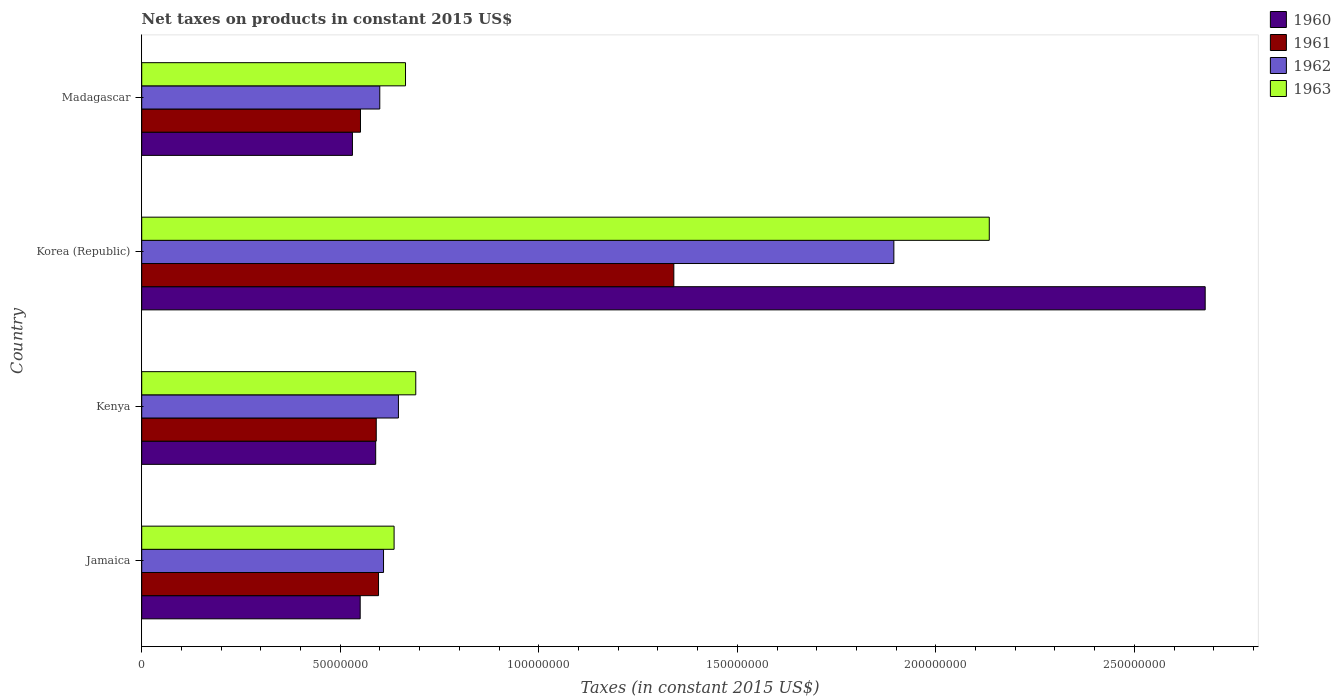Are the number of bars per tick equal to the number of legend labels?
Your answer should be very brief. Yes. Are the number of bars on each tick of the Y-axis equal?
Keep it short and to the point. Yes. How many bars are there on the 3rd tick from the bottom?
Your answer should be compact. 4. What is the label of the 2nd group of bars from the top?
Offer a terse response. Korea (Republic). In how many cases, is the number of bars for a given country not equal to the number of legend labels?
Your answer should be very brief. 0. What is the net taxes on products in 1961 in Madagascar?
Provide a short and direct response. 5.51e+07. Across all countries, what is the maximum net taxes on products in 1961?
Make the answer very short. 1.34e+08. Across all countries, what is the minimum net taxes on products in 1961?
Offer a very short reply. 5.51e+07. In which country was the net taxes on products in 1962 minimum?
Your answer should be very brief. Madagascar. What is the total net taxes on products in 1963 in the graph?
Provide a succinct answer. 4.12e+08. What is the difference between the net taxes on products in 1963 in Kenya and that in Madagascar?
Keep it short and to the point. 2.58e+06. What is the difference between the net taxes on products in 1962 in Jamaica and the net taxes on products in 1960 in Kenya?
Offer a very short reply. 1.97e+06. What is the average net taxes on products in 1961 per country?
Your answer should be compact. 7.70e+07. What is the difference between the net taxes on products in 1961 and net taxes on products in 1960 in Jamaica?
Your answer should be very brief. 4.62e+06. What is the ratio of the net taxes on products in 1960 in Jamaica to that in Korea (Republic)?
Your answer should be compact. 0.21. Is the difference between the net taxes on products in 1961 in Jamaica and Kenya greater than the difference between the net taxes on products in 1960 in Jamaica and Kenya?
Your answer should be very brief. Yes. What is the difference between the highest and the second highest net taxes on products in 1961?
Your answer should be very brief. 7.44e+07. What is the difference between the highest and the lowest net taxes on products in 1963?
Make the answer very short. 1.50e+08. Is the sum of the net taxes on products in 1961 in Kenya and Korea (Republic) greater than the maximum net taxes on products in 1960 across all countries?
Ensure brevity in your answer.  No. What does the 4th bar from the bottom in Madagascar represents?
Offer a terse response. 1963. Are all the bars in the graph horizontal?
Your response must be concise. Yes. How many countries are there in the graph?
Give a very brief answer. 4. What is the difference between two consecutive major ticks on the X-axis?
Your answer should be very brief. 5.00e+07. Are the values on the major ticks of X-axis written in scientific E-notation?
Provide a succinct answer. No. Does the graph contain grids?
Make the answer very short. No. Where does the legend appear in the graph?
Make the answer very short. Top right. How many legend labels are there?
Offer a very short reply. 4. How are the legend labels stacked?
Your answer should be very brief. Vertical. What is the title of the graph?
Keep it short and to the point. Net taxes on products in constant 2015 US$. What is the label or title of the X-axis?
Your answer should be compact. Taxes (in constant 2015 US$). What is the Taxes (in constant 2015 US$) in 1960 in Jamaica?
Keep it short and to the point. 5.50e+07. What is the Taxes (in constant 2015 US$) of 1961 in Jamaica?
Offer a terse response. 5.96e+07. What is the Taxes (in constant 2015 US$) of 1962 in Jamaica?
Give a very brief answer. 6.09e+07. What is the Taxes (in constant 2015 US$) of 1963 in Jamaica?
Keep it short and to the point. 6.36e+07. What is the Taxes (in constant 2015 US$) of 1960 in Kenya?
Your answer should be very brief. 5.89e+07. What is the Taxes (in constant 2015 US$) in 1961 in Kenya?
Ensure brevity in your answer.  5.91e+07. What is the Taxes (in constant 2015 US$) in 1962 in Kenya?
Your answer should be very brief. 6.47e+07. What is the Taxes (in constant 2015 US$) in 1963 in Kenya?
Your response must be concise. 6.90e+07. What is the Taxes (in constant 2015 US$) of 1960 in Korea (Republic)?
Make the answer very short. 2.68e+08. What is the Taxes (in constant 2015 US$) in 1961 in Korea (Republic)?
Make the answer very short. 1.34e+08. What is the Taxes (in constant 2015 US$) in 1962 in Korea (Republic)?
Your answer should be very brief. 1.89e+08. What is the Taxes (in constant 2015 US$) in 1963 in Korea (Republic)?
Provide a succinct answer. 2.13e+08. What is the Taxes (in constant 2015 US$) in 1960 in Madagascar?
Your answer should be compact. 5.31e+07. What is the Taxes (in constant 2015 US$) of 1961 in Madagascar?
Your answer should be very brief. 5.51e+07. What is the Taxes (in constant 2015 US$) in 1962 in Madagascar?
Provide a short and direct response. 6.00e+07. What is the Taxes (in constant 2015 US$) in 1963 in Madagascar?
Give a very brief answer. 6.64e+07. Across all countries, what is the maximum Taxes (in constant 2015 US$) in 1960?
Make the answer very short. 2.68e+08. Across all countries, what is the maximum Taxes (in constant 2015 US$) of 1961?
Your answer should be compact. 1.34e+08. Across all countries, what is the maximum Taxes (in constant 2015 US$) of 1962?
Your answer should be very brief. 1.89e+08. Across all countries, what is the maximum Taxes (in constant 2015 US$) in 1963?
Offer a very short reply. 2.13e+08. Across all countries, what is the minimum Taxes (in constant 2015 US$) of 1960?
Provide a short and direct response. 5.31e+07. Across all countries, what is the minimum Taxes (in constant 2015 US$) of 1961?
Give a very brief answer. 5.51e+07. Across all countries, what is the minimum Taxes (in constant 2015 US$) in 1962?
Make the answer very short. 6.00e+07. Across all countries, what is the minimum Taxes (in constant 2015 US$) of 1963?
Keep it short and to the point. 6.36e+07. What is the total Taxes (in constant 2015 US$) of 1960 in the graph?
Give a very brief answer. 4.35e+08. What is the total Taxes (in constant 2015 US$) in 1961 in the graph?
Your answer should be compact. 3.08e+08. What is the total Taxes (in constant 2015 US$) in 1962 in the graph?
Keep it short and to the point. 3.75e+08. What is the total Taxes (in constant 2015 US$) in 1963 in the graph?
Make the answer very short. 4.12e+08. What is the difference between the Taxes (in constant 2015 US$) of 1960 in Jamaica and that in Kenya?
Your response must be concise. -3.91e+06. What is the difference between the Taxes (in constant 2015 US$) in 1961 in Jamaica and that in Kenya?
Keep it short and to the point. 5.74e+05. What is the difference between the Taxes (in constant 2015 US$) in 1962 in Jamaica and that in Kenya?
Your answer should be very brief. -3.75e+06. What is the difference between the Taxes (in constant 2015 US$) of 1963 in Jamaica and that in Kenya?
Provide a short and direct response. -5.46e+06. What is the difference between the Taxes (in constant 2015 US$) of 1960 in Jamaica and that in Korea (Republic)?
Offer a terse response. -2.13e+08. What is the difference between the Taxes (in constant 2015 US$) of 1961 in Jamaica and that in Korea (Republic)?
Give a very brief answer. -7.44e+07. What is the difference between the Taxes (in constant 2015 US$) in 1962 in Jamaica and that in Korea (Republic)?
Make the answer very short. -1.29e+08. What is the difference between the Taxes (in constant 2015 US$) in 1963 in Jamaica and that in Korea (Republic)?
Make the answer very short. -1.50e+08. What is the difference between the Taxes (in constant 2015 US$) in 1960 in Jamaica and that in Madagascar?
Your answer should be very brief. 1.95e+06. What is the difference between the Taxes (in constant 2015 US$) of 1961 in Jamaica and that in Madagascar?
Provide a short and direct response. 4.55e+06. What is the difference between the Taxes (in constant 2015 US$) in 1962 in Jamaica and that in Madagascar?
Your answer should be compact. 9.44e+05. What is the difference between the Taxes (in constant 2015 US$) of 1963 in Jamaica and that in Madagascar?
Provide a short and direct response. -2.88e+06. What is the difference between the Taxes (in constant 2015 US$) in 1960 in Kenya and that in Korea (Republic)?
Keep it short and to the point. -2.09e+08. What is the difference between the Taxes (in constant 2015 US$) in 1961 in Kenya and that in Korea (Republic)?
Offer a terse response. -7.49e+07. What is the difference between the Taxes (in constant 2015 US$) in 1962 in Kenya and that in Korea (Republic)?
Provide a short and direct response. -1.25e+08. What is the difference between the Taxes (in constant 2015 US$) of 1963 in Kenya and that in Korea (Republic)?
Offer a very short reply. -1.44e+08. What is the difference between the Taxes (in constant 2015 US$) of 1960 in Kenya and that in Madagascar?
Your answer should be compact. 5.86e+06. What is the difference between the Taxes (in constant 2015 US$) of 1961 in Kenya and that in Madagascar?
Keep it short and to the point. 3.97e+06. What is the difference between the Taxes (in constant 2015 US$) of 1962 in Kenya and that in Madagascar?
Give a very brief answer. 4.70e+06. What is the difference between the Taxes (in constant 2015 US$) in 1963 in Kenya and that in Madagascar?
Keep it short and to the point. 2.58e+06. What is the difference between the Taxes (in constant 2015 US$) of 1960 in Korea (Republic) and that in Madagascar?
Provide a succinct answer. 2.15e+08. What is the difference between the Taxes (in constant 2015 US$) in 1961 in Korea (Republic) and that in Madagascar?
Your response must be concise. 7.89e+07. What is the difference between the Taxes (in constant 2015 US$) in 1962 in Korea (Republic) and that in Madagascar?
Ensure brevity in your answer.  1.29e+08. What is the difference between the Taxes (in constant 2015 US$) of 1963 in Korea (Republic) and that in Madagascar?
Your response must be concise. 1.47e+08. What is the difference between the Taxes (in constant 2015 US$) of 1960 in Jamaica and the Taxes (in constant 2015 US$) of 1961 in Kenya?
Give a very brief answer. -4.05e+06. What is the difference between the Taxes (in constant 2015 US$) in 1960 in Jamaica and the Taxes (in constant 2015 US$) in 1962 in Kenya?
Provide a succinct answer. -9.63e+06. What is the difference between the Taxes (in constant 2015 US$) of 1960 in Jamaica and the Taxes (in constant 2015 US$) of 1963 in Kenya?
Ensure brevity in your answer.  -1.40e+07. What is the difference between the Taxes (in constant 2015 US$) in 1961 in Jamaica and the Taxes (in constant 2015 US$) in 1962 in Kenya?
Your response must be concise. -5.01e+06. What is the difference between the Taxes (in constant 2015 US$) in 1961 in Jamaica and the Taxes (in constant 2015 US$) in 1963 in Kenya?
Offer a very short reply. -9.38e+06. What is the difference between the Taxes (in constant 2015 US$) in 1962 in Jamaica and the Taxes (in constant 2015 US$) in 1963 in Kenya?
Offer a very short reply. -8.12e+06. What is the difference between the Taxes (in constant 2015 US$) in 1960 in Jamaica and the Taxes (in constant 2015 US$) in 1961 in Korea (Republic)?
Provide a short and direct response. -7.90e+07. What is the difference between the Taxes (in constant 2015 US$) of 1960 in Jamaica and the Taxes (in constant 2015 US$) of 1962 in Korea (Republic)?
Give a very brief answer. -1.34e+08. What is the difference between the Taxes (in constant 2015 US$) in 1960 in Jamaica and the Taxes (in constant 2015 US$) in 1963 in Korea (Republic)?
Your response must be concise. -1.58e+08. What is the difference between the Taxes (in constant 2015 US$) in 1961 in Jamaica and the Taxes (in constant 2015 US$) in 1962 in Korea (Republic)?
Offer a very short reply. -1.30e+08. What is the difference between the Taxes (in constant 2015 US$) in 1961 in Jamaica and the Taxes (in constant 2015 US$) in 1963 in Korea (Republic)?
Your answer should be very brief. -1.54e+08. What is the difference between the Taxes (in constant 2015 US$) of 1962 in Jamaica and the Taxes (in constant 2015 US$) of 1963 in Korea (Republic)?
Provide a succinct answer. -1.53e+08. What is the difference between the Taxes (in constant 2015 US$) in 1960 in Jamaica and the Taxes (in constant 2015 US$) in 1961 in Madagascar?
Keep it short and to the point. -7.48e+04. What is the difference between the Taxes (in constant 2015 US$) of 1960 in Jamaica and the Taxes (in constant 2015 US$) of 1962 in Madagascar?
Make the answer very short. -4.94e+06. What is the difference between the Taxes (in constant 2015 US$) of 1960 in Jamaica and the Taxes (in constant 2015 US$) of 1963 in Madagascar?
Your response must be concise. -1.14e+07. What is the difference between the Taxes (in constant 2015 US$) of 1961 in Jamaica and the Taxes (in constant 2015 US$) of 1962 in Madagascar?
Your response must be concise. -3.16e+05. What is the difference between the Taxes (in constant 2015 US$) in 1961 in Jamaica and the Taxes (in constant 2015 US$) in 1963 in Madagascar?
Your answer should be very brief. -6.80e+06. What is the difference between the Taxes (in constant 2015 US$) of 1962 in Jamaica and the Taxes (in constant 2015 US$) of 1963 in Madagascar?
Your answer should be compact. -5.54e+06. What is the difference between the Taxes (in constant 2015 US$) in 1960 in Kenya and the Taxes (in constant 2015 US$) in 1961 in Korea (Republic)?
Your answer should be compact. -7.51e+07. What is the difference between the Taxes (in constant 2015 US$) of 1960 in Kenya and the Taxes (in constant 2015 US$) of 1962 in Korea (Republic)?
Provide a short and direct response. -1.31e+08. What is the difference between the Taxes (in constant 2015 US$) of 1960 in Kenya and the Taxes (in constant 2015 US$) of 1963 in Korea (Republic)?
Give a very brief answer. -1.55e+08. What is the difference between the Taxes (in constant 2015 US$) in 1961 in Kenya and the Taxes (in constant 2015 US$) in 1962 in Korea (Republic)?
Provide a succinct answer. -1.30e+08. What is the difference between the Taxes (in constant 2015 US$) of 1961 in Kenya and the Taxes (in constant 2015 US$) of 1963 in Korea (Republic)?
Your answer should be compact. -1.54e+08. What is the difference between the Taxes (in constant 2015 US$) of 1962 in Kenya and the Taxes (in constant 2015 US$) of 1963 in Korea (Republic)?
Provide a short and direct response. -1.49e+08. What is the difference between the Taxes (in constant 2015 US$) in 1960 in Kenya and the Taxes (in constant 2015 US$) in 1961 in Madagascar?
Provide a short and direct response. 3.83e+06. What is the difference between the Taxes (in constant 2015 US$) in 1960 in Kenya and the Taxes (in constant 2015 US$) in 1962 in Madagascar?
Keep it short and to the point. -1.03e+06. What is the difference between the Taxes (in constant 2015 US$) in 1960 in Kenya and the Taxes (in constant 2015 US$) in 1963 in Madagascar?
Give a very brief answer. -7.51e+06. What is the difference between the Taxes (in constant 2015 US$) in 1961 in Kenya and the Taxes (in constant 2015 US$) in 1962 in Madagascar?
Provide a short and direct response. -8.90e+05. What is the difference between the Taxes (in constant 2015 US$) in 1961 in Kenya and the Taxes (in constant 2015 US$) in 1963 in Madagascar?
Provide a short and direct response. -7.37e+06. What is the difference between the Taxes (in constant 2015 US$) in 1962 in Kenya and the Taxes (in constant 2015 US$) in 1963 in Madagascar?
Provide a succinct answer. -1.79e+06. What is the difference between the Taxes (in constant 2015 US$) of 1960 in Korea (Republic) and the Taxes (in constant 2015 US$) of 1961 in Madagascar?
Ensure brevity in your answer.  2.13e+08. What is the difference between the Taxes (in constant 2015 US$) of 1960 in Korea (Republic) and the Taxes (in constant 2015 US$) of 1962 in Madagascar?
Your answer should be very brief. 2.08e+08. What is the difference between the Taxes (in constant 2015 US$) of 1960 in Korea (Republic) and the Taxes (in constant 2015 US$) of 1963 in Madagascar?
Offer a terse response. 2.01e+08. What is the difference between the Taxes (in constant 2015 US$) of 1961 in Korea (Republic) and the Taxes (in constant 2015 US$) of 1962 in Madagascar?
Offer a very short reply. 7.41e+07. What is the difference between the Taxes (in constant 2015 US$) of 1961 in Korea (Republic) and the Taxes (in constant 2015 US$) of 1963 in Madagascar?
Your answer should be compact. 6.76e+07. What is the difference between the Taxes (in constant 2015 US$) of 1962 in Korea (Republic) and the Taxes (in constant 2015 US$) of 1963 in Madagascar?
Provide a short and direct response. 1.23e+08. What is the average Taxes (in constant 2015 US$) in 1960 per country?
Your answer should be compact. 1.09e+08. What is the average Taxes (in constant 2015 US$) in 1961 per country?
Keep it short and to the point. 7.70e+07. What is the average Taxes (in constant 2015 US$) in 1962 per country?
Your answer should be very brief. 9.37e+07. What is the average Taxes (in constant 2015 US$) of 1963 per country?
Your answer should be very brief. 1.03e+08. What is the difference between the Taxes (in constant 2015 US$) of 1960 and Taxes (in constant 2015 US$) of 1961 in Jamaica?
Offer a terse response. -4.62e+06. What is the difference between the Taxes (in constant 2015 US$) in 1960 and Taxes (in constant 2015 US$) in 1962 in Jamaica?
Offer a terse response. -5.88e+06. What is the difference between the Taxes (in constant 2015 US$) of 1960 and Taxes (in constant 2015 US$) of 1963 in Jamaica?
Your response must be concise. -8.54e+06. What is the difference between the Taxes (in constant 2015 US$) in 1961 and Taxes (in constant 2015 US$) in 1962 in Jamaica?
Give a very brief answer. -1.26e+06. What is the difference between the Taxes (in constant 2015 US$) of 1961 and Taxes (in constant 2015 US$) of 1963 in Jamaica?
Your answer should be very brief. -3.92e+06. What is the difference between the Taxes (in constant 2015 US$) of 1962 and Taxes (in constant 2015 US$) of 1963 in Jamaica?
Ensure brevity in your answer.  -2.66e+06. What is the difference between the Taxes (in constant 2015 US$) of 1960 and Taxes (in constant 2015 US$) of 1961 in Kenya?
Ensure brevity in your answer.  -1.40e+05. What is the difference between the Taxes (in constant 2015 US$) of 1960 and Taxes (in constant 2015 US$) of 1962 in Kenya?
Your answer should be very brief. -5.73e+06. What is the difference between the Taxes (in constant 2015 US$) in 1960 and Taxes (in constant 2015 US$) in 1963 in Kenya?
Offer a terse response. -1.01e+07. What is the difference between the Taxes (in constant 2015 US$) of 1961 and Taxes (in constant 2015 US$) of 1962 in Kenya?
Ensure brevity in your answer.  -5.59e+06. What is the difference between the Taxes (in constant 2015 US$) of 1961 and Taxes (in constant 2015 US$) of 1963 in Kenya?
Your answer should be very brief. -9.95e+06. What is the difference between the Taxes (in constant 2015 US$) in 1962 and Taxes (in constant 2015 US$) in 1963 in Kenya?
Offer a very short reply. -4.37e+06. What is the difference between the Taxes (in constant 2015 US$) of 1960 and Taxes (in constant 2015 US$) of 1961 in Korea (Republic)?
Make the answer very short. 1.34e+08. What is the difference between the Taxes (in constant 2015 US$) in 1960 and Taxes (in constant 2015 US$) in 1962 in Korea (Republic)?
Provide a succinct answer. 7.84e+07. What is the difference between the Taxes (in constant 2015 US$) in 1960 and Taxes (in constant 2015 US$) in 1963 in Korea (Republic)?
Your answer should be very brief. 5.44e+07. What is the difference between the Taxes (in constant 2015 US$) in 1961 and Taxes (in constant 2015 US$) in 1962 in Korea (Republic)?
Your answer should be compact. -5.54e+07. What is the difference between the Taxes (in constant 2015 US$) in 1961 and Taxes (in constant 2015 US$) in 1963 in Korea (Republic)?
Provide a short and direct response. -7.94e+07. What is the difference between the Taxes (in constant 2015 US$) of 1962 and Taxes (in constant 2015 US$) of 1963 in Korea (Republic)?
Make the answer very short. -2.40e+07. What is the difference between the Taxes (in constant 2015 US$) of 1960 and Taxes (in constant 2015 US$) of 1961 in Madagascar?
Make the answer very short. -2.03e+06. What is the difference between the Taxes (in constant 2015 US$) in 1960 and Taxes (in constant 2015 US$) in 1962 in Madagascar?
Your answer should be compact. -6.89e+06. What is the difference between the Taxes (in constant 2015 US$) of 1960 and Taxes (in constant 2015 US$) of 1963 in Madagascar?
Your response must be concise. -1.34e+07. What is the difference between the Taxes (in constant 2015 US$) of 1961 and Taxes (in constant 2015 US$) of 1962 in Madagascar?
Your response must be concise. -4.86e+06. What is the difference between the Taxes (in constant 2015 US$) in 1961 and Taxes (in constant 2015 US$) in 1963 in Madagascar?
Your answer should be compact. -1.13e+07. What is the difference between the Taxes (in constant 2015 US$) in 1962 and Taxes (in constant 2015 US$) in 1963 in Madagascar?
Provide a short and direct response. -6.48e+06. What is the ratio of the Taxes (in constant 2015 US$) of 1960 in Jamaica to that in Kenya?
Make the answer very short. 0.93. What is the ratio of the Taxes (in constant 2015 US$) in 1961 in Jamaica to that in Kenya?
Offer a very short reply. 1.01. What is the ratio of the Taxes (in constant 2015 US$) in 1962 in Jamaica to that in Kenya?
Offer a very short reply. 0.94. What is the ratio of the Taxes (in constant 2015 US$) of 1963 in Jamaica to that in Kenya?
Give a very brief answer. 0.92. What is the ratio of the Taxes (in constant 2015 US$) in 1960 in Jamaica to that in Korea (Republic)?
Make the answer very short. 0.21. What is the ratio of the Taxes (in constant 2015 US$) of 1961 in Jamaica to that in Korea (Republic)?
Make the answer very short. 0.45. What is the ratio of the Taxes (in constant 2015 US$) of 1962 in Jamaica to that in Korea (Republic)?
Make the answer very short. 0.32. What is the ratio of the Taxes (in constant 2015 US$) in 1963 in Jamaica to that in Korea (Republic)?
Your answer should be compact. 0.3. What is the ratio of the Taxes (in constant 2015 US$) in 1960 in Jamaica to that in Madagascar?
Make the answer very short. 1.04. What is the ratio of the Taxes (in constant 2015 US$) of 1961 in Jamaica to that in Madagascar?
Provide a succinct answer. 1.08. What is the ratio of the Taxes (in constant 2015 US$) in 1962 in Jamaica to that in Madagascar?
Your answer should be compact. 1.02. What is the ratio of the Taxes (in constant 2015 US$) of 1963 in Jamaica to that in Madagascar?
Your answer should be very brief. 0.96. What is the ratio of the Taxes (in constant 2015 US$) in 1960 in Kenya to that in Korea (Republic)?
Offer a terse response. 0.22. What is the ratio of the Taxes (in constant 2015 US$) in 1961 in Kenya to that in Korea (Republic)?
Provide a short and direct response. 0.44. What is the ratio of the Taxes (in constant 2015 US$) in 1962 in Kenya to that in Korea (Republic)?
Provide a short and direct response. 0.34. What is the ratio of the Taxes (in constant 2015 US$) in 1963 in Kenya to that in Korea (Republic)?
Provide a succinct answer. 0.32. What is the ratio of the Taxes (in constant 2015 US$) in 1960 in Kenya to that in Madagascar?
Keep it short and to the point. 1.11. What is the ratio of the Taxes (in constant 2015 US$) of 1961 in Kenya to that in Madagascar?
Your answer should be compact. 1.07. What is the ratio of the Taxes (in constant 2015 US$) in 1962 in Kenya to that in Madagascar?
Your answer should be compact. 1.08. What is the ratio of the Taxes (in constant 2015 US$) of 1963 in Kenya to that in Madagascar?
Provide a succinct answer. 1.04. What is the ratio of the Taxes (in constant 2015 US$) of 1960 in Korea (Republic) to that in Madagascar?
Ensure brevity in your answer.  5.05. What is the ratio of the Taxes (in constant 2015 US$) in 1961 in Korea (Republic) to that in Madagascar?
Provide a succinct answer. 2.43. What is the ratio of the Taxes (in constant 2015 US$) in 1962 in Korea (Republic) to that in Madagascar?
Give a very brief answer. 3.16. What is the ratio of the Taxes (in constant 2015 US$) in 1963 in Korea (Republic) to that in Madagascar?
Provide a short and direct response. 3.21. What is the difference between the highest and the second highest Taxes (in constant 2015 US$) in 1960?
Your answer should be very brief. 2.09e+08. What is the difference between the highest and the second highest Taxes (in constant 2015 US$) of 1961?
Offer a terse response. 7.44e+07. What is the difference between the highest and the second highest Taxes (in constant 2015 US$) in 1962?
Provide a short and direct response. 1.25e+08. What is the difference between the highest and the second highest Taxes (in constant 2015 US$) in 1963?
Make the answer very short. 1.44e+08. What is the difference between the highest and the lowest Taxes (in constant 2015 US$) in 1960?
Ensure brevity in your answer.  2.15e+08. What is the difference between the highest and the lowest Taxes (in constant 2015 US$) in 1961?
Ensure brevity in your answer.  7.89e+07. What is the difference between the highest and the lowest Taxes (in constant 2015 US$) of 1962?
Ensure brevity in your answer.  1.29e+08. What is the difference between the highest and the lowest Taxes (in constant 2015 US$) of 1963?
Offer a terse response. 1.50e+08. 